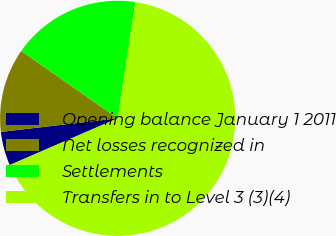Convert chart to OTSL. <chart><loc_0><loc_0><loc_500><loc_500><pie_chart><fcel>Opening balance January 1 2011<fcel>Net losses recognized in<fcel>Settlements<fcel>Transfers in to Level 3 (3)(4)<nl><fcel>4.66%<fcel>11.55%<fcel>17.69%<fcel>66.1%<nl></chart> 